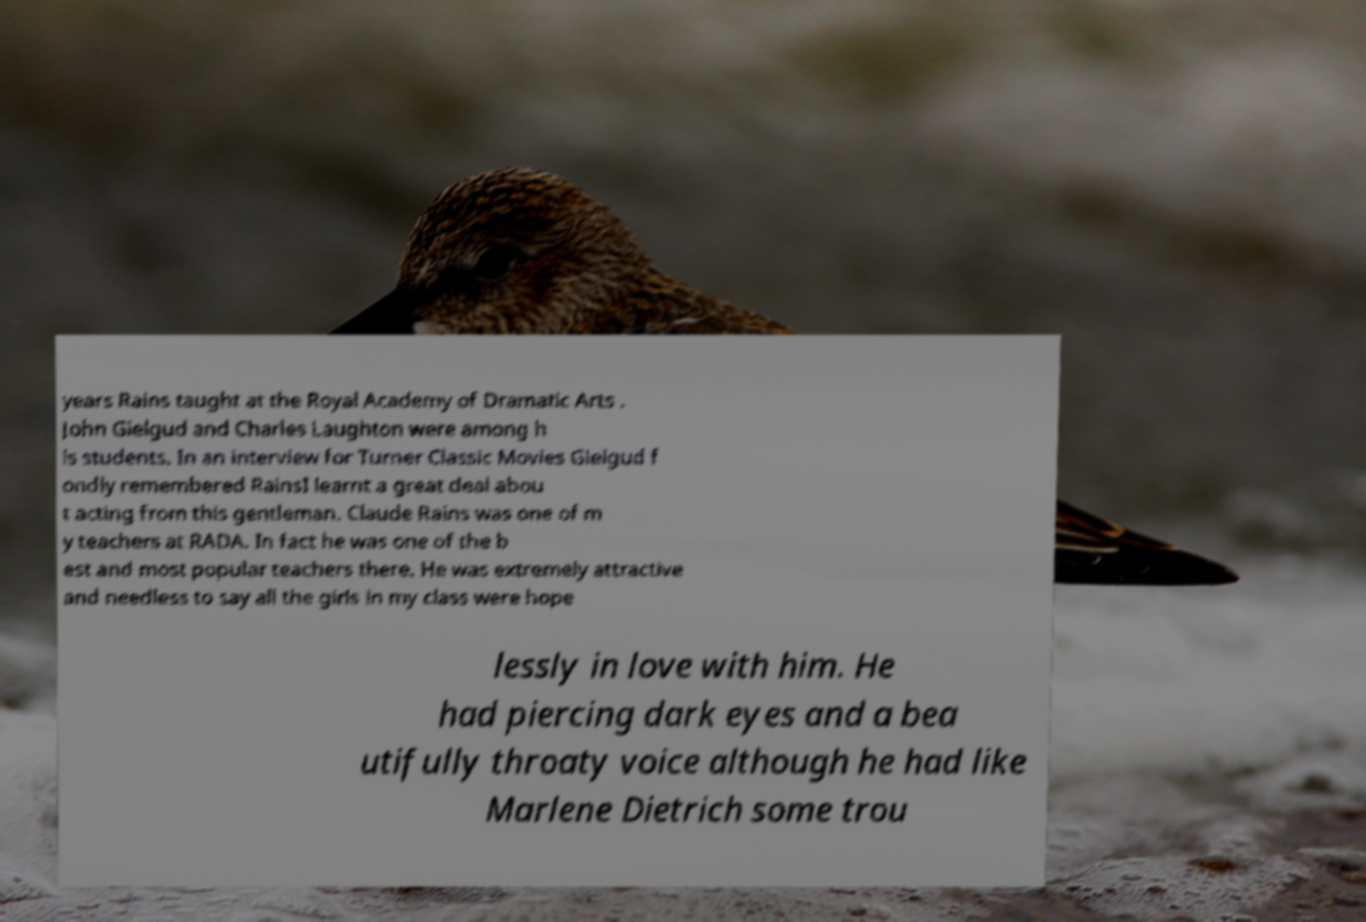Can you read and provide the text displayed in the image?This photo seems to have some interesting text. Can you extract and type it out for me? years Rains taught at the Royal Academy of Dramatic Arts . John Gielgud and Charles Laughton were among h is students. In an interview for Turner Classic Movies Gielgud f ondly remembered RainsI learnt a great deal abou t acting from this gentleman. Claude Rains was one of m y teachers at RADA. In fact he was one of the b est and most popular teachers there. He was extremely attractive and needless to say all the girls in my class were hope lessly in love with him. He had piercing dark eyes and a bea utifully throaty voice although he had like Marlene Dietrich some trou 